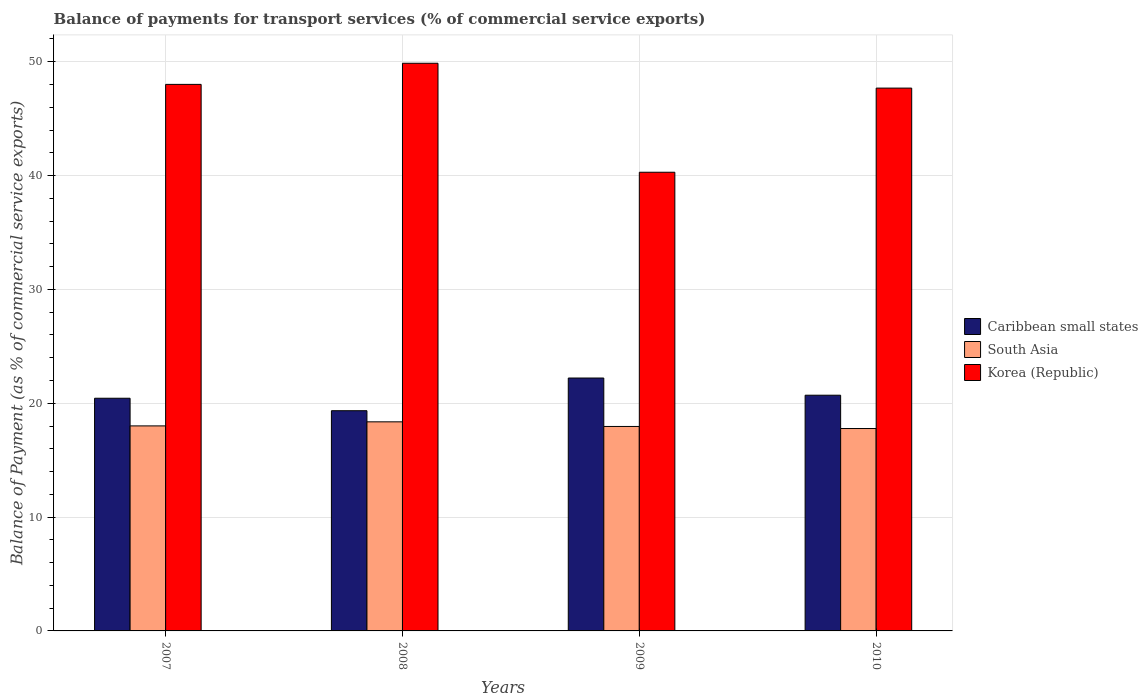How many different coloured bars are there?
Make the answer very short. 3. How many bars are there on the 4th tick from the left?
Offer a very short reply. 3. How many bars are there on the 3rd tick from the right?
Make the answer very short. 3. What is the label of the 1st group of bars from the left?
Your answer should be very brief. 2007. In how many cases, is the number of bars for a given year not equal to the number of legend labels?
Your response must be concise. 0. What is the balance of payments for transport services in South Asia in 2007?
Ensure brevity in your answer.  18.01. Across all years, what is the maximum balance of payments for transport services in Caribbean small states?
Your answer should be compact. 22.22. Across all years, what is the minimum balance of payments for transport services in South Asia?
Keep it short and to the point. 17.78. In which year was the balance of payments for transport services in South Asia maximum?
Give a very brief answer. 2008. What is the total balance of payments for transport services in Caribbean small states in the graph?
Offer a terse response. 82.7. What is the difference between the balance of payments for transport services in Caribbean small states in 2007 and that in 2009?
Make the answer very short. -1.78. What is the difference between the balance of payments for transport services in South Asia in 2008 and the balance of payments for transport services in Korea (Republic) in 2009?
Your response must be concise. -21.92. What is the average balance of payments for transport services in Korea (Republic) per year?
Ensure brevity in your answer.  46.46. In the year 2009, what is the difference between the balance of payments for transport services in Caribbean small states and balance of payments for transport services in South Asia?
Offer a terse response. 4.26. In how many years, is the balance of payments for transport services in Korea (Republic) greater than 20 %?
Your answer should be very brief. 4. What is the ratio of the balance of payments for transport services in Caribbean small states in 2009 to that in 2010?
Your response must be concise. 1.07. What is the difference between the highest and the second highest balance of payments for transport services in South Asia?
Keep it short and to the point. 0.36. What is the difference between the highest and the lowest balance of payments for transport services in South Asia?
Offer a terse response. 0.59. In how many years, is the balance of payments for transport services in Korea (Republic) greater than the average balance of payments for transport services in Korea (Republic) taken over all years?
Provide a succinct answer. 3. What does the 2nd bar from the left in 2009 represents?
Provide a succinct answer. South Asia. What does the 3rd bar from the right in 2009 represents?
Your answer should be compact. Caribbean small states. How many bars are there?
Your answer should be very brief. 12. Are the values on the major ticks of Y-axis written in scientific E-notation?
Your response must be concise. No. Does the graph contain any zero values?
Your answer should be compact. No. How many legend labels are there?
Ensure brevity in your answer.  3. What is the title of the graph?
Keep it short and to the point. Balance of payments for transport services (% of commercial service exports). What is the label or title of the Y-axis?
Give a very brief answer. Balance of Payment (as % of commercial service exports). What is the Balance of Payment (as % of commercial service exports) in Caribbean small states in 2007?
Keep it short and to the point. 20.44. What is the Balance of Payment (as % of commercial service exports) in South Asia in 2007?
Your answer should be very brief. 18.01. What is the Balance of Payment (as % of commercial service exports) in Korea (Republic) in 2007?
Offer a very short reply. 48.01. What is the Balance of Payment (as % of commercial service exports) in Caribbean small states in 2008?
Offer a very short reply. 19.34. What is the Balance of Payment (as % of commercial service exports) of South Asia in 2008?
Provide a succinct answer. 18.37. What is the Balance of Payment (as % of commercial service exports) of Korea (Republic) in 2008?
Offer a terse response. 49.86. What is the Balance of Payment (as % of commercial service exports) in Caribbean small states in 2009?
Provide a short and direct response. 22.22. What is the Balance of Payment (as % of commercial service exports) of South Asia in 2009?
Provide a succinct answer. 17.96. What is the Balance of Payment (as % of commercial service exports) in Korea (Republic) in 2009?
Make the answer very short. 40.29. What is the Balance of Payment (as % of commercial service exports) in Caribbean small states in 2010?
Keep it short and to the point. 20.71. What is the Balance of Payment (as % of commercial service exports) in South Asia in 2010?
Ensure brevity in your answer.  17.78. What is the Balance of Payment (as % of commercial service exports) of Korea (Republic) in 2010?
Keep it short and to the point. 47.68. Across all years, what is the maximum Balance of Payment (as % of commercial service exports) in Caribbean small states?
Offer a very short reply. 22.22. Across all years, what is the maximum Balance of Payment (as % of commercial service exports) of South Asia?
Offer a terse response. 18.37. Across all years, what is the maximum Balance of Payment (as % of commercial service exports) in Korea (Republic)?
Offer a terse response. 49.86. Across all years, what is the minimum Balance of Payment (as % of commercial service exports) of Caribbean small states?
Make the answer very short. 19.34. Across all years, what is the minimum Balance of Payment (as % of commercial service exports) in South Asia?
Offer a terse response. 17.78. Across all years, what is the minimum Balance of Payment (as % of commercial service exports) of Korea (Republic)?
Provide a succinct answer. 40.29. What is the total Balance of Payment (as % of commercial service exports) in Caribbean small states in the graph?
Keep it short and to the point. 82.7. What is the total Balance of Payment (as % of commercial service exports) of South Asia in the graph?
Keep it short and to the point. 72.12. What is the total Balance of Payment (as % of commercial service exports) of Korea (Republic) in the graph?
Offer a terse response. 185.85. What is the difference between the Balance of Payment (as % of commercial service exports) of Caribbean small states in 2007 and that in 2008?
Your answer should be compact. 1.1. What is the difference between the Balance of Payment (as % of commercial service exports) of South Asia in 2007 and that in 2008?
Offer a terse response. -0.36. What is the difference between the Balance of Payment (as % of commercial service exports) of Korea (Republic) in 2007 and that in 2008?
Offer a very short reply. -1.86. What is the difference between the Balance of Payment (as % of commercial service exports) of Caribbean small states in 2007 and that in 2009?
Offer a terse response. -1.78. What is the difference between the Balance of Payment (as % of commercial service exports) of South Asia in 2007 and that in 2009?
Offer a very short reply. 0.05. What is the difference between the Balance of Payment (as % of commercial service exports) of Korea (Republic) in 2007 and that in 2009?
Make the answer very short. 7.72. What is the difference between the Balance of Payment (as % of commercial service exports) of Caribbean small states in 2007 and that in 2010?
Provide a succinct answer. -0.27. What is the difference between the Balance of Payment (as % of commercial service exports) in South Asia in 2007 and that in 2010?
Your answer should be compact. 0.23. What is the difference between the Balance of Payment (as % of commercial service exports) of Korea (Republic) in 2007 and that in 2010?
Make the answer very short. 0.33. What is the difference between the Balance of Payment (as % of commercial service exports) in Caribbean small states in 2008 and that in 2009?
Give a very brief answer. -2.87. What is the difference between the Balance of Payment (as % of commercial service exports) of South Asia in 2008 and that in 2009?
Your answer should be very brief. 0.41. What is the difference between the Balance of Payment (as % of commercial service exports) in Korea (Republic) in 2008 and that in 2009?
Offer a terse response. 9.57. What is the difference between the Balance of Payment (as % of commercial service exports) in Caribbean small states in 2008 and that in 2010?
Your response must be concise. -1.36. What is the difference between the Balance of Payment (as % of commercial service exports) of South Asia in 2008 and that in 2010?
Ensure brevity in your answer.  0.59. What is the difference between the Balance of Payment (as % of commercial service exports) in Korea (Republic) in 2008 and that in 2010?
Your answer should be very brief. 2.18. What is the difference between the Balance of Payment (as % of commercial service exports) in Caribbean small states in 2009 and that in 2010?
Give a very brief answer. 1.51. What is the difference between the Balance of Payment (as % of commercial service exports) in South Asia in 2009 and that in 2010?
Ensure brevity in your answer.  0.18. What is the difference between the Balance of Payment (as % of commercial service exports) of Korea (Republic) in 2009 and that in 2010?
Ensure brevity in your answer.  -7.39. What is the difference between the Balance of Payment (as % of commercial service exports) of Caribbean small states in 2007 and the Balance of Payment (as % of commercial service exports) of South Asia in 2008?
Give a very brief answer. 2.07. What is the difference between the Balance of Payment (as % of commercial service exports) of Caribbean small states in 2007 and the Balance of Payment (as % of commercial service exports) of Korea (Republic) in 2008?
Offer a very short reply. -29.43. What is the difference between the Balance of Payment (as % of commercial service exports) in South Asia in 2007 and the Balance of Payment (as % of commercial service exports) in Korea (Republic) in 2008?
Your answer should be very brief. -31.86. What is the difference between the Balance of Payment (as % of commercial service exports) of Caribbean small states in 2007 and the Balance of Payment (as % of commercial service exports) of South Asia in 2009?
Ensure brevity in your answer.  2.48. What is the difference between the Balance of Payment (as % of commercial service exports) in Caribbean small states in 2007 and the Balance of Payment (as % of commercial service exports) in Korea (Republic) in 2009?
Make the answer very short. -19.85. What is the difference between the Balance of Payment (as % of commercial service exports) of South Asia in 2007 and the Balance of Payment (as % of commercial service exports) of Korea (Republic) in 2009?
Offer a terse response. -22.28. What is the difference between the Balance of Payment (as % of commercial service exports) of Caribbean small states in 2007 and the Balance of Payment (as % of commercial service exports) of South Asia in 2010?
Ensure brevity in your answer.  2.66. What is the difference between the Balance of Payment (as % of commercial service exports) in Caribbean small states in 2007 and the Balance of Payment (as % of commercial service exports) in Korea (Republic) in 2010?
Your answer should be compact. -27.24. What is the difference between the Balance of Payment (as % of commercial service exports) in South Asia in 2007 and the Balance of Payment (as % of commercial service exports) in Korea (Republic) in 2010?
Your answer should be compact. -29.67. What is the difference between the Balance of Payment (as % of commercial service exports) in Caribbean small states in 2008 and the Balance of Payment (as % of commercial service exports) in South Asia in 2009?
Offer a terse response. 1.38. What is the difference between the Balance of Payment (as % of commercial service exports) of Caribbean small states in 2008 and the Balance of Payment (as % of commercial service exports) of Korea (Republic) in 2009?
Offer a terse response. -20.95. What is the difference between the Balance of Payment (as % of commercial service exports) of South Asia in 2008 and the Balance of Payment (as % of commercial service exports) of Korea (Republic) in 2009?
Keep it short and to the point. -21.92. What is the difference between the Balance of Payment (as % of commercial service exports) of Caribbean small states in 2008 and the Balance of Payment (as % of commercial service exports) of South Asia in 2010?
Make the answer very short. 1.56. What is the difference between the Balance of Payment (as % of commercial service exports) of Caribbean small states in 2008 and the Balance of Payment (as % of commercial service exports) of Korea (Republic) in 2010?
Make the answer very short. -28.34. What is the difference between the Balance of Payment (as % of commercial service exports) in South Asia in 2008 and the Balance of Payment (as % of commercial service exports) in Korea (Republic) in 2010?
Your answer should be compact. -29.32. What is the difference between the Balance of Payment (as % of commercial service exports) of Caribbean small states in 2009 and the Balance of Payment (as % of commercial service exports) of South Asia in 2010?
Provide a short and direct response. 4.44. What is the difference between the Balance of Payment (as % of commercial service exports) of Caribbean small states in 2009 and the Balance of Payment (as % of commercial service exports) of Korea (Republic) in 2010?
Provide a succinct answer. -25.47. What is the difference between the Balance of Payment (as % of commercial service exports) of South Asia in 2009 and the Balance of Payment (as % of commercial service exports) of Korea (Republic) in 2010?
Your answer should be compact. -29.72. What is the average Balance of Payment (as % of commercial service exports) in Caribbean small states per year?
Ensure brevity in your answer.  20.68. What is the average Balance of Payment (as % of commercial service exports) in South Asia per year?
Ensure brevity in your answer.  18.03. What is the average Balance of Payment (as % of commercial service exports) of Korea (Republic) per year?
Your answer should be compact. 46.46. In the year 2007, what is the difference between the Balance of Payment (as % of commercial service exports) in Caribbean small states and Balance of Payment (as % of commercial service exports) in South Asia?
Give a very brief answer. 2.43. In the year 2007, what is the difference between the Balance of Payment (as % of commercial service exports) in Caribbean small states and Balance of Payment (as % of commercial service exports) in Korea (Republic)?
Keep it short and to the point. -27.57. In the year 2007, what is the difference between the Balance of Payment (as % of commercial service exports) of South Asia and Balance of Payment (as % of commercial service exports) of Korea (Republic)?
Offer a very short reply. -30. In the year 2008, what is the difference between the Balance of Payment (as % of commercial service exports) in Caribbean small states and Balance of Payment (as % of commercial service exports) in South Asia?
Provide a short and direct response. 0.98. In the year 2008, what is the difference between the Balance of Payment (as % of commercial service exports) of Caribbean small states and Balance of Payment (as % of commercial service exports) of Korea (Republic)?
Provide a short and direct response. -30.52. In the year 2008, what is the difference between the Balance of Payment (as % of commercial service exports) in South Asia and Balance of Payment (as % of commercial service exports) in Korea (Republic)?
Make the answer very short. -31.5. In the year 2009, what is the difference between the Balance of Payment (as % of commercial service exports) of Caribbean small states and Balance of Payment (as % of commercial service exports) of South Asia?
Make the answer very short. 4.26. In the year 2009, what is the difference between the Balance of Payment (as % of commercial service exports) of Caribbean small states and Balance of Payment (as % of commercial service exports) of Korea (Republic)?
Ensure brevity in your answer.  -18.08. In the year 2009, what is the difference between the Balance of Payment (as % of commercial service exports) in South Asia and Balance of Payment (as % of commercial service exports) in Korea (Republic)?
Provide a succinct answer. -22.33. In the year 2010, what is the difference between the Balance of Payment (as % of commercial service exports) of Caribbean small states and Balance of Payment (as % of commercial service exports) of South Asia?
Offer a very short reply. 2.93. In the year 2010, what is the difference between the Balance of Payment (as % of commercial service exports) of Caribbean small states and Balance of Payment (as % of commercial service exports) of Korea (Republic)?
Keep it short and to the point. -26.98. In the year 2010, what is the difference between the Balance of Payment (as % of commercial service exports) in South Asia and Balance of Payment (as % of commercial service exports) in Korea (Republic)?
Provide a short and direct response. -29.9. What is the ratio of the Balance of Payment (as % of commercial service exports) in Caribbean small states in 2007 to that in 2008?
Your answer should be very brief. 1.06. What is the ratio of the Balance of Payment (as % of commercial service exports) in South Asia in 2007 to that in 2008?
Your response must be concise. 0.98. What is the ratio of the Balance of Payment (as % of commercial service exports) in Korea (Republic) in 2007 to that in 2008?
Provide a short and direct response. 0.96. What is the ratio of the Balance of Payment (as % of commercial service exports) of South Asia in 2007 to that in 2009?
Your response must be concise. 1. What is the ratio of the Balance of Payment (as % of commercial service exports) in Korea (Republic) in 2007 to that in 2009?
Your response must be concise. 1.19. What is the ratio of the Balance of Payment (as % of commercial service exports) in Caribbean small states in 2007 to that in 2010?
Give a very brief answer. 0.99. What is the ratio of the Balance of Payment (as % of commercial service exports) of South Asia in 2007 to that in 2010?
Keep it short and to the point. 1.01. What is the ratio of the Balance of Payment (as % of commercial service exports) of Korea (Republic) in 2007 to that in 2010?
Offer a very short reply. 1.01. What is the ratio of the Balance of Payment (as % of commercial service exports) of Caribbean small states in 2008 to that in 2009?
Keep it short and to the point. 0.87. What is the ratio of the Balance of Payment (as % of commercial service exports) in South Asia in 2008 to that in 2009?
Your answer should be very brief. 1.02. What is the ratio of the Balance of Payment (as % of commercial service exports) in Korea (Republic) in 2008 to that in 2009?
Offer a very short reply. 1.24. What is the ratio of the Balance of Payment (as % of commercial service exports) of Caribbean small states in 2008 to that in 2010?
Your answer should be very brief. 0.93. What is the ratio of the Balance of Payment (as % of commercial service exports) of South Asia in 2008 to that in 2010?
Offer a very short reply. 1.03. What is the ratio of the Balance of Payment (as % of commercial service exports) of Korea (Republic) in 2008 to that in 2010?
Give a very brief answer. 1.05. What is the ratio of the Balance of Payment (as % of commercial service exports) of Caribbean small states in 2009 to that in 2010?
Provide a succinct answer. 1.07. What is the ratio of the Balance of Payment (as % of commercial service exports) of South Asia in 2009 to that in 2010?
Offer a very short reply. 1.01. What is the ratio of the Balance of Payment (as % of commercial service exports) in Korea (Republic) in 2009 to that in 2010?
Keep it short and to the point. 0.84. What is the difference between the highest and the second highest Balance of Payment (as % of commercial service exports) of Caribbean small states?
Your answer should be compact. 1.51. What is the difference between the highest and the second highest Balance of Payment (as % of commercial service exports) of South Asia?
Ensure brevity in your answer.  0.36. What is the difference between the highest and the second highest Balance of Payment (as % of commercial service exports) in Korea (Republic)?
Offer a very short reply. 1.86. What is the difference between the highest and the lowest Balance of Payment (as % of commercial service exports) of Caribbean small states?
Provide a short and direct response. 2.87. What is the difference between the highest and the lowest Balance of Payment (as % of commercial service exports) of South Asia?
Offer a terse response. 0.59. What is the difference between the highest and the lowest Balance of Payment (as % of commercial service exports) in Korea (Republic)?
Provide a succinct answer. 9.57. 